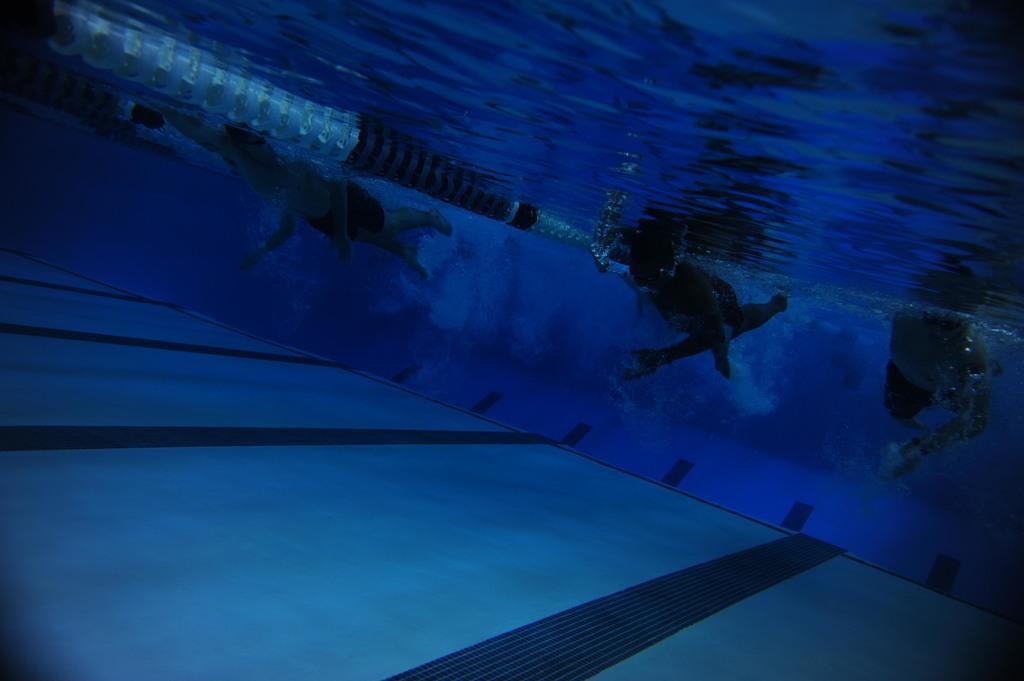How would you summarize this image in a sentence or two? In the image i can see the inside view of the swimming pool that includes people,floor and water. 